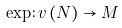Convert formula to latex. <formula><loc_0><loc_0><loc_500><loc_500>\exp \colon v \left ( N \right ) \rightarrow M</formula> 